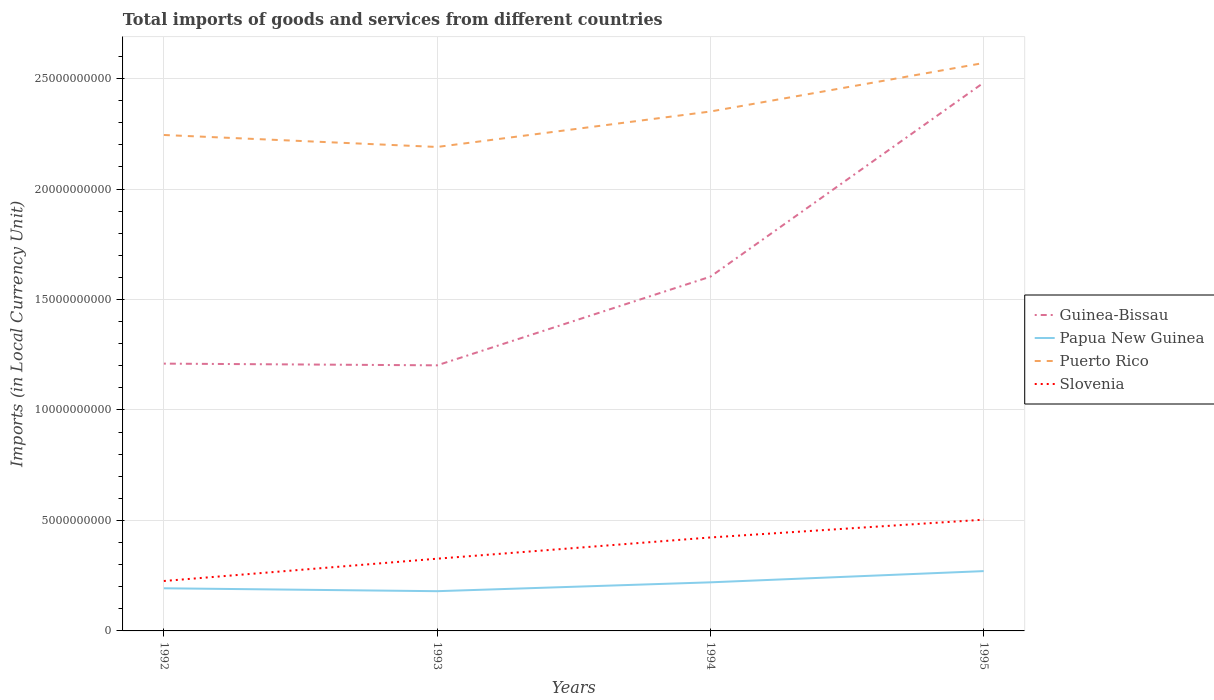How many different coloured lines are there?
Your answer should be compact. 4. Does the line corresponding to Guinea-Bissau intersect with the line corresponding to Slovenia?
Your response must be concise. No. Is the number of lines equal to the number of legend labels?
Offer a terse response. Yes. Across all years, what is the maximum Amount of goods and services imports in Slovenia?
Provide a short and direct response. 2.26e+09. What is the total Amount of goods and services imports in Puerto Rico in the graph?
Provide a succinct answer. -1.06e+09. What is the difference between the highest and the second highest Amount of goods and services imports in Slovenia?
Make the answer very short. 2.78e+09. Does the graph contain any zero values?
Your response must be concise. No. Does the graph contain grids?
Make the answer very short. Yes. What is the title of the graph?
Ensure brevity in your answer.  Total imports of goods and services from different countries. What is the label or title of the Y-axis?
Provide a short and direct response. Imports (in Local Currency Unit). What is the Imports (in Local Currency Unit) of Guinea-Bissau in 1992?
Provide a succinct answer. 1.21e+1. What is the Imports (in Local Currency Unit) of Papua New Guinea in 1992?
Give a very brief answer. 1.93e+09. What is the Imports (in Local Currency Unit) in Puerto Rico in 1992?
Offer a very short reply. 2.24e+1. What is the Imports (in Local Currency Unit) in Slovenia in 1992?
Provide a succinct answer. 2.26e+09. What is the Imports (in Local Currency Unit) of Guinea-Bissau in 1993?
Your answer should be very brief. 1.20e+1. What is the Imports (in Local Currency Unit) in Papua New Guinea in 1993?
Keep it short and to the point. 1.80e+09. What is the Imports (in Local Currency Unit) in Puerto Rico in 1993?
Give a very brief answer. 2.19e+1. What is the Imports (in Local Currency Unit) of Slovenia in 1993?
Provide a short and direct response. 3.27e+09. What is the Imports (in Local Currency Unit) of Guinea-Bissau in 1994?
Offer a terse response. 1.60e+1. What is the Imports (in Local Currency Unit) of Papua New Guinea in 1994?
Your answer should be compact. 2.20e+09. What is the Imports (in Local Currency Unit) of Puerto Rico in 1994?
Your answer should be compact. 2.35e+1. What is the Imports (in Local Currency Unit) in Slovenia in 1994?
Offer a terse response. 4.23e+09. What is the Imports (in Local Currency Unit) in Guinea-Bissau in 1995?
Your answer should be compact. 2.48e+1. What is the Imports (in Local Currency Unit) of Papua New Guinea in 1995?
Your response must be concise. 2.71e+09. What is the Imports (in Local Currency Unit) of Puerto Rico in 1995?
Offer a very short reply. 2.57e+1. What is the Imports (in Local Currency Unit) in Slovenia in 1995?
Your response must be concise. 5.04e+09. Across all years, what is the maximum Imports (in Local Currency Unit) of Guinea-Bissau?
Keep it short and to the point. 2.48e+1. Across all years, what is the maximum Imports (in Local Currency Unit) in Papua New Guinea?
Provide a short and direct response. 2.71e+09. Across all years, what is the maximum Imports (in Local Currency Unit) of Puerto Rico?
Offer a terse response. 2.57e+1. Across all years, what is the maximum Imports (in Local Currency Unit) of Slovenia?
Your answer should be compact. 5.04e+09. Across all years, what is the minimum Imports (in Local Currency Unit) of Guinea-Bissau?
Ensure brevity in your answer.  1.20e+1. Across all years, what is the minimum Imports (in Local Currency Unit) in Papua New Guinea?
Make the answer very short. 1.80e+09. Across all years, what is the minimum Imports (in Local Currency Unit) in Puerto Rico?
Keep it short and to the point. 2.19e+1. Across all years, what is the minimum Imports (in Local Currency Unit) in Slovenia?
Offer a terse response. 2.26e+09. What is the total Imports (in Local Currency Unit) of Guinea-Bissau in the graph?
Your response must be concise. 6.50e+1. What is the total Imports (in Local Currency Unit) of Papua New Guinea in the graph?
Your response must be concise. 8.63e+09. What is the total Imports (in Local Currency Unit) of Puerto Rico in the graph?
Ensure brevity in your answer.  9.36e+1. What is the total Imports (in Local Currency Unit) in Slovenia in the graph?
Provide a succinct answer. 1.48e+1. What is the difference between the Imports (in Local Currency Unit) in Guinea-Bissau in 1992 and that in 1993?
Offer a very short reply. 7.73e+07. What is the difference between the Imports (in Local Currency Unit) in Papua New Guinea in 1992 and that in 1993?
Give a very brief answer. 1.32e+08. What is the difference between the Imports (in Local Currency Unit) in Puerto Rico in 1992 and that in 1993?
Your answer should be very brief. 5.42e+08. What is the difference between the Imports (in Local Currency Unit) of Slovenia in 1992 and that in 1993?
Ensure brevity in your answer.  -1.01e+09. What is the difference between the Imports (in Local Currency Unit) of Guinea-Bissau in 1992 and that in 1994?
Make the answer very short. -3.94e+09. What is the difference between the Imports (in Local Currency Unit) of Papua New Guinea in 1992 and that in 1994?
Provide a succinct answer. -2.69e+08. What is the difference between the Imports (in Local Currency Unit) of Puerto Rico in 1992 and that in 1994?
Your response must be concise. -1.06e+09. What is the difference between the Imports (in Local Currency Unit) of Slovenia in 1992 and that in 1994?
Your answer should be compact. -1.97e+09. What is the difference between the Imports (in Local Currency Unit) of Guinea-Bissau in 1992 and that in 1995?
Keep it short and to the point. -1.27e+1. What is the difference between the Imports (in Local Currency Unit) of Papua New Guinea in 1992 and that in 1995?
Your answer should be very brief. -7.77e+08. What is the difference between the Imports (in Local Currency Unit) in Puerto Rico in 1992 and that in 1995?
Provide a succinct answer. -3.26e+09. What is the difference between the Imports (in Local Currency Unit) in Slovenia in 1992 and that in 1995?
Your answer should be very brief. -2.78e+09. What is the difference between the Imports (in Local Currency Unit) in Guinea-Bissau in 1993 and that in 1994?
Ensure brevity in your answer.  -4.01e+09. What is the difference between the Imports (in Local Currency Unit) in Papua New Guinea in 1993 and that in 1994?
Offer a terse response. -4.01e+08. What is the difference between the Imports (in Local Currency Unit) in Puerto Rico in 1993 and that in 1994?
Offer a very short reply. -1.60e+09. What is the difference between the Imports (in Local Currency Unit) of Slovenia in 1993 and that in 1994?
Ensure brevity in your answer.  -9.61e+08. What is the difference between the Imports (in Local Currency Unit) of Guinea-Bissau in 1993 and that in 1995?
Your answer should be compact. -1.28e+1. What is the difference between the Imports (in Local Currency Unit) of Papua New Guinea in 1993 and that in 1995?
Offer a very short reply. -9.09e+08. What is the difference between the Imports (in Local Currency Unit) in Puerto Rico in 1993 and that in 1995?
Give a very brief answer. -3.80e+09. What is the difference between the Imports (in Local Currency Unit) of Slovenia in 1993 and that in 1995?
Your answer should be compact. -1.77e+09. What is the difference between the Imports (in Local Currency Unit) of Guinea-Bissau in 1994 and that in 1995?
Your answer should be very brief. -8.78e+09. What is the difference between the Imports (in Local Currency Unit) in Papua New Guinea in 1994 and that in 1995?
Provide a short and direct response. -5.08e+08. What is the difference between the Imports (in Local Currency Unit) of Puerto Rico in 1994 and that in 1995?
Provide a short and direct response. -2.20e+09. What is the difference between the Imports (in Local Currency Unit) in Slovenia in 1994 and that in 1995?
Your response must be concise. -8.05e+08. What is the difference between the Imports (in Local Currency Unit) in Guinea-Bissau in 1992 and the Imports (in Local Currency Unit) in Papua New Guinea in 1993?
Give a very brief answer. 1.03e+1. What is the difference between the Imports (in Local Currency Unit) of Guinea-Bissau in 1992 and the Imports (in Local Currency Unit) of Puerto Rico in 1993?
Ensure brevity in your answer.  -9.81e+09. What is the difference between the Imports (in Local Currency Unit) in Guinea-Bissau in 1992 and the Imports (in Local Currency Unit) in Slovenia in 1993?
Provide a short and direct response. 8.83e+09. What is the difference between the Imports (in Local Currency Unit) of Papua New Guinea in 1992 and the Imports (in Local Currency Unit) of Puerto Rico in 1993?
Your answer should be very brief. -2.00e+1. What is the difference between the Imports (in Local Currency Unit) of Papua New Guinea in 1992 and the Imports (in Local Currency Unit) of Slovenia in 1993?
Make the answer very short. -1.34e+09. What is the difference between the Imports (in Local Currency Unit) in Puerto Rico in 1992 and the Imports (in Local Currency Unit) in Slovenia in 1993?
Provide a succinct answer. 1.92e+1. What is the difference between the Imports (in Local Currency Unit) of Guinea-Bissau in 1992 and the Imports (in Local Currency Unit) of Papua New Guinea in 1994?
Your response must be concise. 9.90e+09. What is the difference between the Imports (in Local Currency Unit) in Guinea-Bissau in 1992 and the Imports (in Local Currency Unit) in Puerto Rico in 1994?
Make the answer very short. -1.14e+1. What is the difference between the Imports (in Local Currency Unit) of Guinea-Bissau in 1992 and the Imports (in Local Currency Unit) of Slovenia in 1994?
Your answer should be very brief. 7.87e+09. What is the difference between the Imports (in Local Currency Unit) in Papua New Guinea in 1992 and the Imports (in Local Currency Unit) in Puerto Rico in 1994?
Ensure brevity in your answer.  -2.16e+1. What is the difference between the Imports (in Local Currency Unit) of Papua New Guinea in 1992 and the Imports (in Local Currency Unit) of Slovenia in 1994?
Provide a succinct answer. -2.30e+09. What is the difference between the Imports (in Local Currency Unit) in Puerto Rico in 1992 and the Imports (in Local Currency Unit) in Slovenia in 1994?
Keep it short and to the point. 1.82e+1. What is the difference between the Imports (in Local Currency Unit) of Guinea-Bissau in 1992 and the Imports (in Local Currency Unit) of Papua New Guinea in 1995?
Provide a succinct answer. 9.39e+09. What is the difference between the Imports (in Local Currency Unit) of Guinea-Bissau in 1992 and the Imports (in Local Currency Unit) of Puerto Rico in 1995?
Your answer should be very brief. -1.36e+1. What is the difference between the Imports (in Local Currency Unit) in Guinea-Bissau in 1992 and the Imports (in Local Currency Unit) in Slovenia in 1995?
Offer a terse response. 7.06e+09. What is the difference between the Imports (in Local Currency Unit) in Papua New Guinea in 1992 and the Imports (in Local Currency Unit) in Puerto Rico in 1995?
Offer a terse response. -2.38e+1. What is the difference between the Imports (in Local Currency Unit) in Papua New Guinea in 1992 and the Imports (in Local Currency Unit) in Slovenia in 1995?
Provide a short and direct response. -3.11e+09. What is the difference between the Imports (in Local Currency Unit) of Puerto Rico in 1992 and the Imports (in Local Currency Unit) of Slovenia in 1995?
Give a very brief answer. 1.74e+1. What is the difference between the Imports (in Local Currency Unit) of Guinea-Bissau in 1993 and the Imports (in Local Currency Unit) of Papua New Guinea in 1994?
Your response must be concise. 9.82e+09. What is the difference between the Imports (in Local Currency Unit) in Guinea-Bissau in 1993 and the Imports (in Local Currency Unit) in Puerto Rico in 1994?
Ensure brevity in your answer.  -1.15e+1. What is the difference between the Imports (in Local Currency Unit) in Guinea-Bissau in 1993 and the Imports (in Local Currency Unit) in Slovenia in 1994?
Your answer should be compact. 7.79e+09. What is the difference between the Imports (in Local Currency Unit) of Papua New Guinea in 1993 and the Imports (in Local Currency Unit) of Puerto Rico in 1994?
Make the answer very short. -2.17e+1. What is the difference between the Imports (in Local Currency Unit) of Papua New Guinea in 1993 and the Imports (in Local Currency Unit) of Slovenia in 1994?
Your response must be concise. -2.43e+09. What is the difference between the Imports (in Local Currency Unit) of Puerto Rico in 1993 and the Imports (in Local Currency Unit) of Slovenia in 1994?
Your answer should be very brief. 1.77e+1. What is the difference between the Imports (in Local Currency Unit) of Guinea-Bissau in 1993 and the Imports (in Local Currency Unit) of Papua New Guinea in 1995?
Your answer should be very brief. 9.31e+09. What is the difference between the Imports (in Local Currency Unit) of Guinea-Bissau in 1993 and the Imports (in Local Currency Unit) of Puerto Rico in 1995?
Provide a short and direct response. -1.37e+1. What is the difference between the Imports (in Local Currency Unit) in Guinea-Bissau in 1993 and the Imports (in Local Currency Unit) in Slovenia in 1995?
Give a very brief answer. 6.99e+09. What is the difference between the Imports (in Local Currency Unit) of Papua New Guinea in 1993 and the Imports (in Local Currency Unit) of Puerto Rico in 1995?
Offer a very short reply. -2.39e+1. What is the difference between the Imports (in Local Currency Unit) in Papua New Guinea in 1993 and the Imports (in Local Currency Unit) in Slovenia in 1995?
Ensure brevity in your answer.  -3.24e+09. What is the difference between the Imports (in Local Currency Unit) of Puerto Rico in 1993 and the Imports (in Local Currency Unit) of Slovenia in 1995?
Offer a very short reply. 1.69e+1. What is the difference between the Imports (in Local Currency Unit) in Guinea-Bissau in 1994 and the Imports (in Local Currency Unit) in Papua New Guinea in 1995?
Provide a succinct answer. 1.33e+1. What is the difference between the Imports (in Local Currency Unit) in Guinea-Bissau in 1994 and the Imports (in Local Currency Unit) in Puerto Rico in 1995?
Offer a terse response. -9.67e+09. What is the difference between the Imports (in Local Currency Unit) of Guinea-Bissau in 1994 and the Imports (in Local Currency Unit) of Slovenia in 1995?
Your response must be concise. 1.10e+1. What is the difference between the Imports (in Local Currency Unit) of Papua New Guinea in 1994 and the Imports (in Local Currency Unit) of Puerto Rico in 1995?
Offer a terse response. -2.35e+1. What is the difference between the Imports (in Local Currency Unit) of Papua New Guinea in 1994 and the Imports (in Local Currency Unit) of Slovenia in 1995?
Ensure brevity in your answer.  -2.84e+09. What is the difference between the Imports (in Local Currency Unit) of Puerto Rico in 1994 and the Imports (in Local Currency Unit) of Slovenia in 1995?
Provide a short and direct response. 1.85e+1. What is the average Imports (in Local Currency Unit) in Guinea-Bissau per year?
Your response must be concise. 1.62e+1. What is the average Imports (in Local Currency Unit) in Papua New Guinea per year?
Offer a very short reply. 2.16e+09. What is the average Imports (in Local Currency Unit) of Puerto Rico per year?
Give a very brief answer. 2.34e+1. What is the average Imports (in Local Currency Unit) in Slovenia per year?
Your response must be concise. 3.70e+09. In the year 1992, what is the difference between the Imports (in Local Currency Unit) of Guinea-Bissau and Imports (in Local Currency Unit) of Papua New Guinea?
Your answer should be compact. 1.02e+1. In the year 1992, what is the difference between the Imports (in Local Currency Unit) of Guinea-Bissau and Imports (in Local Currency Unit) of Puerto Rico?
Make the answer very short. -1.03e+1. In the year 1992, what is the difference between the Imports (in Local Currency Unit) of Guinea-Bissau and Imports (in Local Currency Unit) of Slovenia?
Provide a short and direct response. 9.84e+09. In the year 1992, what is the difference between the Imports (in Local Currency Unit) in Papua New Guinea and Imports (in Local Currency Unit) in Puerto Rico?
Offer a very short reply. -2.05e+1. In the year 1992, what is the difference between the Imports (in Local Currency Unit) in Papua New Guinea and Imports (in Local Currency Unit) in Slovenia?
Provide a short and direct response. -3.30e+08. In the year 1992, what is the difference between the Imports (in Local Currency Unit) of Puerto Rico and Imports (in Local Currency Unit) of Slovenia?
Provide a short and direct response. 2.02e+1. In the year 1993, what is the difference between the Imports (in Local Currency Unit) in Guinea-Bissau and Imports (in Local Currency Unit) in Papua New Guinea?
Provide a succinct answer. 1.02e+1. In the year 1993, what is the difference between the Imports (in Local Currency Unit) in Guinea-Bissau and Imports (in Local Currency Unit) in Puerto Rico?
Your response must be concise. -9.88e+09. In the year 1993, what is the difference between the Imports (in Local Currency Unit) of Guinea-Bissau and Imports (in Local Currency Unit) of Slovenia?
Make the answer very short. 8.75e+09. In the year 1993, what is the difference between the Imports (in Local Currency Unit) in Papua New Guinea and Imports (in Local Currency Unit) in Puerto Rico?
Offer a very short reply. -2.01e+1. In the year 1993, what is the difference between the Imports (in Local Currency Unit) in Papua New Guinea and Imports (in Local Currency Unit) in Slovenia?
Ensure brevity in your answer.  -1.47e+09. In the year 1993, what is the difference between the Imports (in Local Currency Unit) of Puerto Rico and Imports (in Local Currency Unit) of Slovenia?
Keep it short and to the point. 1.86e+1. In the year 1994, what is the difference between the Imports (in Local Currency Unit) in Guinea-Bissau and Imports (in Local Currency Unit) in Papua New Guinea?
Ensure brevity in your answer.  1.38e+1. In the year 1994, what is the difference between the Imports (in Local Currency Unit) in Guinea-Bissau and Imports (in Local Currency Unit) in Puerto Rico?
Your response must be concise. -7.48e+09. In the year 1994, what is the difference between the Imports (in Local Currency Unit) in Guinea-Bissau and Imports (in Local Currency Unit) in Slovenia?
Offer a terse response. 1.18e+1. In the year 1994, what is the difference between the Imports (in Local Currency Unit) of Papua New Guinea and Imports (in Local Currency Unit) of Puerto Rico?
Offer a very short reply. -2.13e+1. In the year 1994, what is the difference between the Imports (in Local Currency Unit) in Papua New Guinea and Imports (in Local Currency Unit) in Slovenia?
Ensure brevity in your answer.  -2.03e+09. In the year 1994, what is the difference between the Imports (in Local Currency Unit) in Puerto Rico and Imports (in Local Currency Unit) in Slovenia?
Provide a succinct answer. 1.93e+1. In the year 1995, what is the difference between the Imports (in Local Currency Unit) in Guinea-Bissau and Imports (in Local Currency Unit) in Papua New Guinea?
Your answer should be compact. 2.21e+1. In the year 1995, what is the difference between the Imports (in Local Currency Unit) of Guinea-Bissau and Imports (in Local Currency Unit) of Puerto Rico?
Make the answer very short. -8.89e+08. In the year 1995, what is the difference between the Imports (in Local Currency Unit) in Guinea-Bissau and Imports (in Local Currency Unit) in Slovenia?
Keep it short and to the point. 1.98e+1. In the year 1995, what is the difference between the Imports (in Local Currency Unit) of Papua New Guinea and Imports (in Local Currency Unit) of Puerto Rico?
Your response must be concise. -2.30e+1. In the year 1995, what is the difference between the Imports (in Local Currency Unit) in Papua New Guinea and Imports (in Local Currency Unit) in Slovenia?
Make the answer very short. -2.33e+09. In the year 1995, what is the difference between the Imports (in Local Currency Unit) of Puerto Rico and Imports (in Local Currency Unit) of Slovenia?
Offer a very short reply. 2.07e+1. What is the ratio of the Imports (in Local Currency Unit) in Guinea-Bissau in 1992 to that in 1993?
Your response must be concise. 1.01. What is the ratio of the Imports (in Local Currency Unit) of Papua New Guinea in 1992 to that in 1993?
Your answer should be compact. 1.07. What is the ratio of the Imports (in Local Currency Unit) of Puerto Rico in 1992 to that in 1993?
Provide a succinct answer. 1.02. What is the ratio of the Imports (in Local Currency Unit) of Slovenia in 1992 to that in 1993?
Ensure brevity in your answer.  0.69. What is the ratio of the Imports (in Local Currency Unit) of Guinea-Bissau in 1992 to that in 1994?
Your response must be concise. 0.75. What is the ratio of the Imports (in Local Currency Unit) of Papua New Guinea in 1992 to that in 1994?
Make the answer very short. 0.88. What is the ratio of the Imports (in Local Currency Unit) in Puerto Rico in 1992 to that in 1994?
Your response must be concise. 0.95. What is the ratio of the Imports (in Local Currency Unit) of Slovenia in 1992 to that in 1994?
Make the answer very short. 0.53. What is the ratio of the Imports (in Local Currency Unit) of Guinea-Bissau in 1992 to that in 1995?
Your answer should be very brief. 0.49. What is the ratio of the Imports (in Local Currency Unit) of Papua New Guinea in 1992 to that in 1995?
Offer a terse response. 0.71. What is the ratio of the Imports (in Local Currency Unit) of Puerto Rico in 1992 to that in 1995?
Offer a very short reply. 0.87. What is the ratio of the Imports (in Local Currency Unit) of Slovenia in 1992 to that in 1995?
Offer a very short reply. 0.45. What is the ratio of the Imports (in Local Currency Unit) in Guinea-Bissau in 1993 to that in 1994?
Keep it short and to the point. 0.75. What is the ratio of the Imports (in Local Currency Unit) in Papua New Guinea in 1993 to that in 1994?
Provide a succinct answer. 0.82. What is the ratio of the Imports (in Local Currency Unit) in Puerto Rico in 1993 to that in 1994?
Ensure brevity in your answer.  0.93. What is the ratio of the Imports (in Local Currency Unit) in Slovenia in 1993 to that in 1994?
Keep it short and to the point. 0.77. What is the ratio of the Imports (in Local Currency Unit) of Guinea-Bissau in 1993 to that in 1995?
Your response must be concise. 0.48. What is the ratio of the Imports (in Local Currency Unit) in Papua New Guinea in 1993 to that in 1995?
Make the answer very short. 0.66. What is the ratio of the Imports (in Local Currency Unit) of Puerto Rico in 1993 to that in 1995?
Your answer should be compact. 0.85. What is the ratio of the Imports (in Local Currency Unit) of Slovenia in 1993 to that in 1995?
Provide a succinct answer. 0.65. What is the ratio of the Imports (in Local Currency Unit) in Guinea-Bissau in 1994 to that in 1995?
Give a very brief answer. 0.65. What is the ratio of the Imports (in Local Currency Unit) in Papua New Guinea in 1994 to that in 1995?
Ensure brevity in your answer.  0.81. What is the ratio of the Imports (in Local Currency Unit) of Puerto Rico in 1994 to that in 1995?
Give a very brief answer. 0.91. What is the ratio of the Imports (in Local Currency Unit) of Slovenia in 1994 to that in 1995?
Keep it short and to the point. 0.84. What is the difference between the highest and the second highest Imports (in Local Currency Unit) of Guinea-Bissau?
Make the answer very short. 8.78e+09. What is the difference between the highest and the second highest Imports (in Local Currency Unit) of Papua New Guinea?
Your response must be concise. 5.08e+08. What is the difference between the highest and the second highest Imports (in Local Currency Unit) in Puerto Rico?
Provide a succinct answer. 2.20e+09. What is the difference between the highest and the second highest Imports (in Local Currency Unit) in Slovenia?
Provide a succinct answer. 8.05e+08. What is the difference between the highest and the lowest Imports (in Local Currency Unit) of Guinea-Bissau?
Keep it short and to the point. 1.28e+1. What is the difference between the highest and the lowest Imports (in Local Currency Unit) in Papua New Guinea?
Give a very brief answer. 9.09e+08. What is the difference between the highest and the lowest Imports (in Local Currency Unit) in Puerto Rico?
Make the answer very short. 3.80e+09. What is the difference between the highest and the lowest Imports (in Local Currency Unit) of Slovenia?
Offer a terse response. 2.78e+09. 